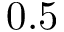Convert formula to latex. <formula><loc_0><loc_0><loc_500><loc_500>0 . 5</formula> 